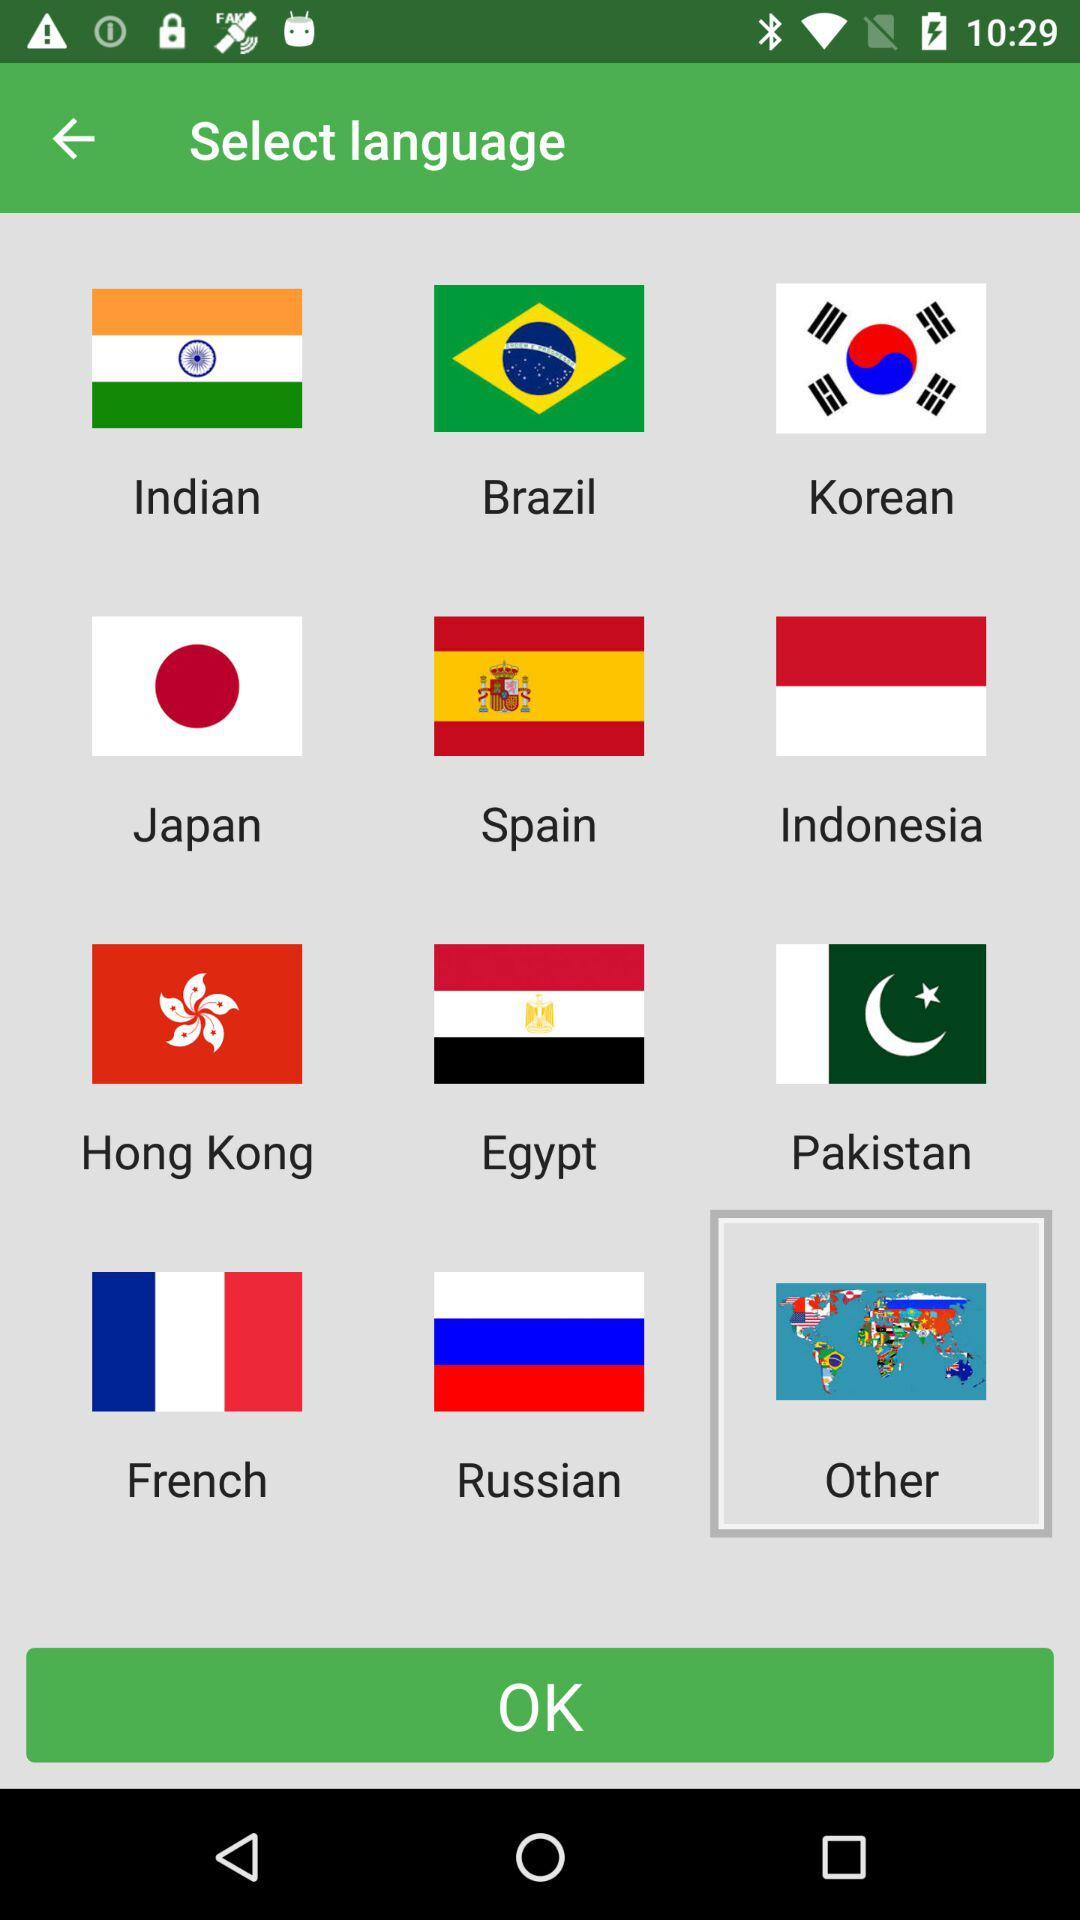Which option has been selected? The option "Other" has been selected. 